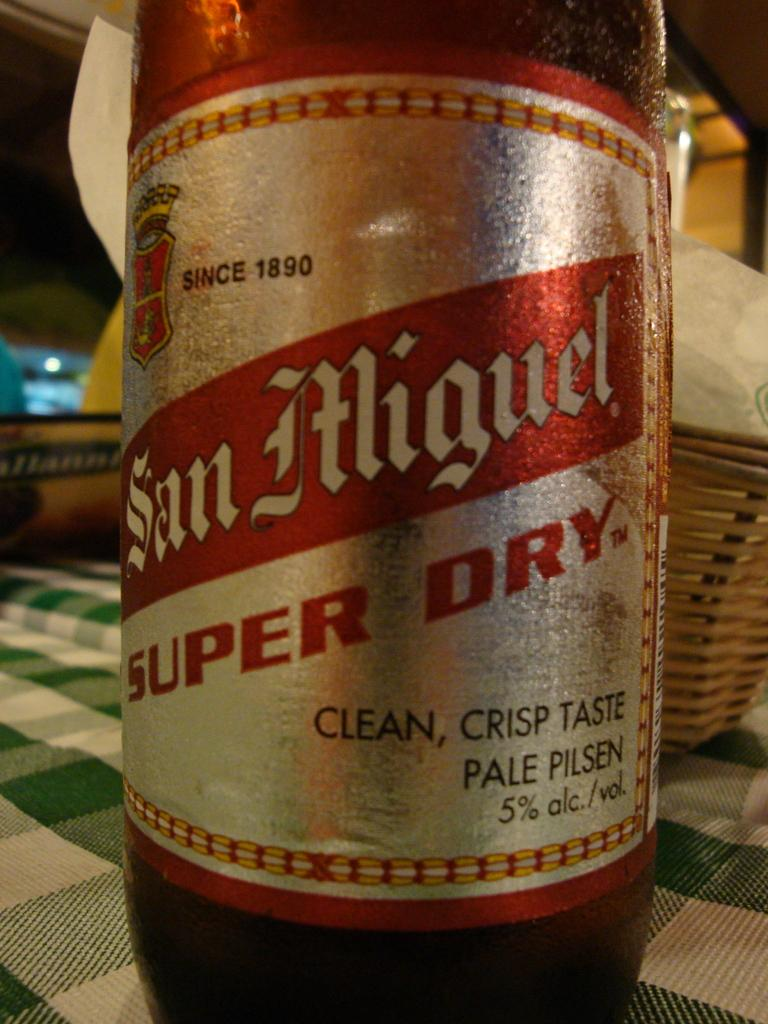<image>
Render a clear and concise summary of the photo. A bottle of San Miguel beer is the super dry variety. 